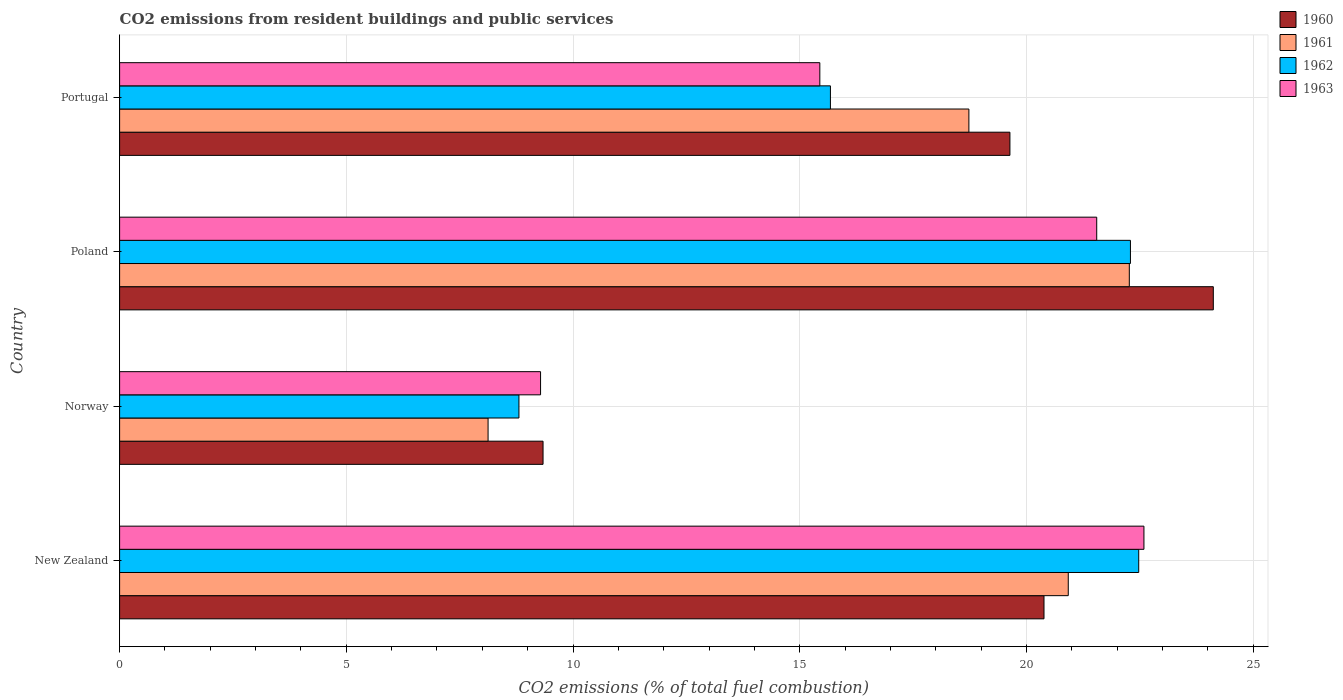Are the number of bars per tick equal to the number of legend labels?
Provide a short and direct response. Yes. Are the number of bars on each tick of the Y-axis equal?
Give a very brief answer. Yes. How many bars are there on the 1st tick from the bottom?
Keep it short and to the point. 4. What is the label of the 4th group of bars from the top?
Offer a terse response. New Zealand. In how many cases, is the number of bars for a given country not equal to the number of legend labels?
Your answer should be compact. 0. What is the total CO2 emitted in 1963 in Portugal?
Your response must be concise. 15.44. Across all countries, what is the maximum total CO2 emitted in 1963?
Make the answer very short. 22.59. Across all countries, what is the minimum total CO2 emitted in 1961?
Keep it short and to the point. 8.13. In which country was the total CO2 emitted in 1962 maximum?
Give a very brief answer. New Zealand. What is the total total CO2 emitted in 1963 in the graph?
Your response must be concise. 68.87. What is the difference between the total CO2 emitted in 1963 in Norway and that in Portugal?
Provide a succinct answer. -6.16. What is the difference between the total CO2 emitted in 1963 in Portugal and the total CO2 emitted in 1961 in Norway?
Offer a very short reply. 7.32. What is the average total CO2 emitted in 1962 per country?
Provide a succinct answer. 17.31. What is the difference between the total CO2 emitted in 1962 and total CO2 emitted in 1963 in Norway?
Provide a short and direct response. -0.48. In how many countries, is the total CO2 emitted in 1960 greater than 1 ?
Ensure brevity in your answer.  4. What is the ratio of the total CO2 emitted in 1960 in Poland to that in Portugal?
Keep it short and to the point. 1.23. Is the total CO2 emitted in 1962 in Poland less than that in Portugal?
Your response must be concise. No. Is the difference between the total CO2 emitted in 1962 in Norway and Poland greater than the difference between the total CO2 emitted in 1963 in Norway and Poland?
Ensure brevity in your answer.  No. What is the difference between the highest and the second highest total CO2 emitted in 1962?
Offer a terse response. 0.18. What is the difference between the highest and the lowest total CO2 emitted in 1960?
Keep it short and to the point. 14.78. Is it the case that in every country, the sum of the total CO2 emitted in 1962 and total CO2 emitted in 1961 is greater than the sum of total CO2 emitted in 1963 and total CO2 emitted in 1960?
Your response must be concise. No. What does the 1st bar from the top in Norway represents?
Provide a short and direct response. 1963. How many bars are there?
Offer a very short reply. 16. How many countries are there in the graph?
Give a very brief answer. 4. Does the graph contain grids?
Offer a terse response. Yes. Where does the legend appear in the graph?
Keep it short and to the point. Top right. How are the legend labels stacked?
Offer a terse response. Vertical. What is the title of the graph?
Give a very brief answer. CO2 emissions from resident buildings and public services. What is the label or title of the X-axis?
Provide a short and direct response. CO2 emissions (% of total fuel combustion). What is the CO2 emissions (% of total fuel combustion) in 1960 in New Zealand?
Your response must be concise. 20.39. What is the CO2 emissions (% of total fuel combustion) in 1961 in New Zealand?
Make the answer very short. 20.92. What is the CO2 emissions (% of total fuel combustion) of 1962 in New Zealand?
Offer a terse response. 22.48. What is the CO2 emissions (% of total fuel combustion) of 1963 in New Zealand?
Offer a terse response. 22.59. What is the CO2 emissions (% of total fuel combustion) in 1960 in Norway?
Ensure brevity in your answer.  9.34. What is the CO2 emissions (% of total fuel combustion) in 1961 in Norway?
Provide a short and direct response. 8.13. What is the CO2 emissions (% of total fuel combustion) in 1962 in Norway?
Your response must be concise. 8.81. What is the CO2 emissions (% of total fuel combustion) in 1963 in Norway?
Your answer should be compact. 9.28. What is the CO2 emissions (% of total fuel combustion) of 1960 in Poland?
Offer a terse response. 24.12. What is the CO2 emissions (% of total fuel combustion) in 1961 in Poland?
Provide a succinct answer. 22.27. What is the CO2 emissions (% of total fuel combustion) in 1962 in Poland?
Make the answer very short. 22.3. What is the CO2 emissions (% of total fuel combustion) of 1963 in Poland?
Make the answer very short. 21.55. What is the CO2 emissions (% of total fuel combustion) of 1960 in Portugal?
Give a very brief answer. 19.64. What is the CO2 emissions (% of total fuel combustion) of 1961 in Portugal?
Make the answer very short. 18.73. What is the CO2 emissions (% of total fuel combustion) in 1962 in Portugal?
Keep it short and to the point. 15.68. What is the CO2 emissions (% of total fuel combustion) in 1963 in Portugal?
Provide a short and direct response. 15.44. Across all countries, what is the maximum CO2 emissions (% of total fuel combustion) of 1960?
Offer a very short reply. 24.12. Across all countries, what is the maximum CO2 emissions (% of total fuel combustion) in 1961?
Offer a terse response. 22.27. Across all countries, what is the maximum CO2 emissions (% of total fuel combustion) in 1962?
Offer a very short reply. 22.48. Across all countries, what is the maximum CO2 emissions (% of total fuel combustion) in 1963?
Make the answer very short. 22.59. Across all countries, what is the minimum CO2 emissions (% of total fuel combustion) of 1960?
Provide a succinct answer. 9.34. Across all countries, what is the minimum CO2 emissions (% of total fuel combustion) of 1961?
Keep it short and to the point. 8.13. Across all countries, what is the minimum CO2 emissions (% of total fuel combustion) in 1962?
Offer a terse response. 8.81. Across all countries, what is the minimum CO2 emissions (% of total fuel combustion) in 1963?
Provide a short and direct response. 9.28. What is the total CO2 emissions (% of total fuel combustion) in 1960 in the graph?
Give a very brief answer. 73.49. What is the total CO2 emissions (% of total fuel combustion) in 1961 in the graph?
Your response must be concise. 70.05. What is the total CO2 emissions (% of total fuel combustion) of 1962 in the graph?
Provide a succinct answer. 69.26. What is the total CO2 emissions (% of total fuel combustion) in 1963 in the graph?
Your answer should be very brief. 68.87. What is the difference between the CO2 emissions (% of total fuel combustion) of 1960 in New Zealand and that in Norway?
Offer a very short reply. 11.05. What is the difference between the CO2 emissions (% of total fuel combustion) in 1961 in New Zealand and that in Norway?
Offer a very short reply. 12.8. What is the difference between the CO2 emissions (% of total fuel combustion) in 1962 in New Zealand and that in Norway?
Keep it short and to the point. 13.67. What is the difference between the CO2 emissions (% of total fuel combustion) of 1963 in New Zealand and that in Norway?
Ensure brevity in your answer.  13.31. What is the difference between the CO2 emissions (% of total fuel combustion) in 1960 in New Zealand and that in Poland?
Offer a terse response. -3.73. What is the difference between the CO2 emissions (% of total fuel combustion) in 1961 in New Zealand and that in Poland?
Give a very brief answer. -1.35. What is the difference between the CO2 emissions (% of total fuel combustion) in 1962 in New Zealand and that in Poland?
Provide a succinct answer. 0.18. What is the difference between the CO2 emissions (% of total fuel combustion) in 1963 in New Zealand and that in Poland?
Offer a terse response. 1.04. What is the difference between the CO2 emissions (% of total fuel combustion) of 1960 in New Zealand and that in Portugal?
Provide a short and direct response. 0.75. What is the difference between the CO2 emissions (% of total fuel combustion) in 1961 in New Zealand and that in Portugal?
Offer a very short reply. 2.19. What is the difference between the CO2 emissions (% of total fuel combustion) in 1962 in New Zealand and that in Portugal?
Give a very brief answer. 6.8. What is the difference between the CO2 emissions (% of total fuel combustion) of 1963 in New Zealand and that in Portugal?
Offer a terse response. 7.15. What is the difference between the CO2 emissions (% of total fuel combustion) in 1960 in Norway and that in Poland?
Make the answer very short. -14.78. What is the difference between the CO2 emissions (% of total fuel combustion) of 1961 in Norway and that in Poland?
Provide a succinct answer. -14.14. What is the difference between the CO2 emissions (% of total fuel combustion) of 1962 in Norway and that in Poland?
Your response must be concise. -13.49. What is the difference between the CO2 emissions (% of total fuel combustion) in 1963 in Norway and that in Poland?
Give a very brief answer. -12.27. What is the difference between the CO2 emissions (% of total fuel combustion) of 1960 in Norway and that in Portugal?
Give a very brief answer. -10.3. What is the difference between the CO2 emissions (% of total fuel combustion) in 1961 in Norway and that in Portugal?
Make the answer very short. -10.61. What is the difference between the CO2 emissions (% of total fuel combustion) in 1962 in Norway and that in Portugal?
Your answer should be very brief. -6.87. What is the difference between the CO2 emissions (% of total fuel combustion) of 1963 in Norway and that in Portugal?
Offer a terse response. -6.16. What is the difference between the CO2 emissions (% of total fuel combustion) of 1960 in Poland and that in Portugal?
Make the answer very short. 4.49. What is the difference between the CO2 emissions (% of total fuel combustion) of 1961 in Poland and that in Portugal?
Keep it short and to the point. 3.54. What is the difference between the CO2 emissions (% of total fuel combustion) of 1962 in Poland and that in Portugal?
Offer a terse response. 6.62. What is the difference between the CO2 emissions (% of total fuel combustion) of 1963 in Poland and that in Portugal?
Make the answer very short. 6.11. What is the difference between the CO2 emissions (% of total fuel combustion) of 1960 in New Zealand and the CO2 emissions (% of total fuel combustion) of 1961 in Norway?
Keep it short and to the point. 12.26. What is the difference between the CO2 emissions (% of total fuel combustion) in 1960 in New Zealand and the CO2 emissions (% of total fuel combustion) in 1962 in Norway?
Offer a very short reply. 11.58. What is the difference between the CO2 emissions (% of total fuel combustion) of 1960 in New Zealand and the CO2 emissions (% of total fuel combustion) of 1963 in Norway?
Provide a short and direct response. 11.1. What is the difference between the CO2 emissions (% of total fuel combustion) of 1961 in New Zealand and the CO2 emissions (% of total fuel combustion) of 1962 in Norway?
Give a very brief answer. 12.12. What is the difference between the CO2 emissions (% of total fuel combustion) in 1961 in New Zealand and the CO2 emissions (% of total fuel combustion) in 1963 in Norway?
Your response must be concise. 11.64. What is the difference between the CO2 emissions (% of total fuel combustion) of 1962 in New Zealand and the CO2 emissions (% of total fuel combustion) of 1963 in Norway?
Make the answer very short. 13.19. What is the difference between the CO2 emissions (% of total fuel combustion) of 1960 in New Zealand and the CO2 emissions (% of total fuel combustion) of 1961 in Poland?
Keep it short and to the point. -1.88. What is the difference between the CO2 emissions (% of total fuel combustion) of 1960 in New Zealand and the CO2 emissions (% of total fuel combustion) of 1962 in Poland?
Your answer should be compact. -1.91. What is the difference between the CO2 emissions (% of total fuel combustion) in 1960 in New Zealand and the CO2 emissions (% of total fuel combustion) in 1963 in Poland?
Provide a short and direct response. -1.16. What is the difference between the CO2 emissions (% of total fuel combustion) in 1961 in New Zealand and the CO2 emissions (% of total fuel combustion) in 1962 in Poland?
Provide a short and direct response. -1.37. What is the difference between the CO2 emissions (% of total fuel combustion) of 1961 in New Zealand and the CO2 emissions (% of total fuel combustion) of 1963 in Poland?
Offer a terse response. -0.63. What is the difference between the CO2 emissions (% of total fuel combustion) of 1962 in New Zealand and the CO2 emissions (% of total fuel combustion) of 1963 in Poland?
Your response must be concise. 0.93. What is the difference between the CO2 emissions (% of total fuel combustion) of 1960 in New Zealand and the CO2 emissions (% of total fuel combustion) of 1961 in Portugal?
Give a very brief answer. 1.66. What is the difference between the CO2 emissions (% of total fuel combustion) in 1960 in New Zealand and the CO2 emissions (% of total fuel combustion) in 1962 in Portugal?
Provide a succinct answer. 4.71. What is the difference between the CO2 emissions (% of total fuel combustion) of 1960 in New Zealand and the CO2 emissions (% of total fuel combustion) of 1963 in Portugal?
Offer a very short reply. 4.94. What is the difference between the CO2 emissions (% of total fuel combustion) of 1961 in New Zealand and the CO2 emissions (% of total fuel combustion) of 1962 in Portugal?
Provide a succinct answer. 5.25. What is the difference between the CO2 emissions (% of total fuel combustion) in 1961 in New Zealand and the CO2 emissions (% of total fuel combustion) in 1963 in Portugal?
Your response must be concise. 5.48. What is the difference between the CO2 emissions (% of total fuel combustion) in 1962 in New Zealand and the CO2 emissions (% of total fuel combustion) in 1963 in Portugal?
Keep it short and to the point. 7.03. What is the difference between the CO2 emissions (% of total fuel combustion) of 1960 in Norway and the CO2 emissions (% of total fuel combustion) of 1961 in Poland?
Ensure brevity in your answer.  -12.93. What is the difference between the CO2 emissions (% of total fuel combustion) of 1960 in Norway and the CO2 emissions (% of total fuel combustion) of 1962 in Poland?
Make the answer very short. -12.96. What is the difference between the CO2 emissions (% of total fuel combustion) in 1960 in Norway and the CO2 emissions (% of total fuel combustion) in 1963 in Poland?
Keep it short and to the point. -12.21. What is the difference between the CO2 emissions (% of total fuel combustion) of 1961 in Norway and the CO2 emissions (% of total fuel combustion) of 1962 in Poland?
Make the answer very short. -14.17. What is the difference between the CO2 emissions (% of total fuel combustion) of 1961 in Norway and the CO2 emissions (% of total fuel combustion) of 1963 in Poland?
Give a very brief answer. -13.42. What is the difference between the CO2 emissions (% of total fuel combustion) in 1962 in Norway and the CO2 emissions (% of total fuel combustion) in 1963 in Poland?
Offer a very short reply. -12.74. What is the difference between the CO2 emissions (% of total fuel combustion) in 1960 in Norway and the CO2 emissions (% of total fuel combustion) in 1961 in Portugal?
Make the answer very short. -9.39. What is the difference between the CO2 emissions (% of total fuel combustion) in 1960 in Norway and the CO2 emissions (% of total fuel combustion) in 1962 in Portugal?
Your answer should be very brief. -6.34. What is the difference between the CO2 emissions (% of total fuel combustion) of 1960 in Norway and the CO2 emissions (% of total fuel combustion) of 1963 in Portugal?
Offer a terse response. -6.1. What is the difference between the CO2 emissions (% of total fuel combustion) in 1961 in Norway and the CO2 emissions (% of total fuel combustion) in 1962 in Portugal?
Provide a succinct answer. -7.55. What is the difference between the CO2 emissions (% of total fuel combustion) in 1961 in Norway and the CO2 emissions (% of total fuel combustion) in 1963 in Portugal?
Provide a short and direct response. -7.32. What is the difference between the CO2 emissions (% of total fuel combustion) in 1962 in Norway and the CO2 emissions (% of total fuel combustion) in 1963 in Portugal?
Your answer should be compact. -6.64. What is the difference between the CO2 emissions (% of total fuel combustion) of 1960 in Poland and the CO2 emissions (% of total fuel combustion) of 1961 in Portugal?
Keep it short and to the point. 5.39. What is the difference between the CO2 emissions (% of total fuel combustion) of 1960 in Poland and the CO2 emissions (% of total fuel combustion) of 1962 in Portugal?
Provide a succinct answer. 8.44. What is the difference between the CO2 emissions (% of total fuel combustion) of 1960 in Poland and the CO2 emissions (% of total fuel combustion) of 1963 in Portugal?
Give a very brief answer. 8.68. What is the difference between the CO2 emissions (% of total fuel combustion) of 1961 in Poland and the CO2 emissions (% of total fuel combustion) of 1962 in Portugal?
Keep it short and to the point. 6.59. What is the difference between the CO2 emissions (% of total fuel combustion) of 1961 in Poland and the CO2 emissions (% of total fuel combustion) of 1963 in Portugal?
Your answer should be compact. 6.83. What is the difference between the CO2 emissions (% of total fuel combustion) of 1962 in Poland and the CO2 emissions (% of total fuel combustion) of 1963 in Portugal?
Make the answer very short. 6.85. What is the average CO2 emissions (% of total fuel combustion) of 1960 per country?
Ensure brevity in your answer.  18.37. What is the average CO2 emissions (% of total fuel combustion) in 1961 per country?
Make the answer very short. 17.51. What is the average CO2 emissions (% of total fuel combustion) in 1962 per country?
Provide a short and direct response. 17.31. What is the average CO2 emissions (% of total fuel combustion) of 1963 per country?
Make the answer very short. 17.22. What is the difference between the CO2 emissions (% of total fuel combustion) of 1960 and CO2 emissions (% of total fuel combustion) of 1961 in New Zealand?
Give a very brief answer. -0.54. What is the difference between the CO2 emissions (% of total fuel combustion) in 1960 and CO2 emissions (% of total fuel combustion) in 1962 in New Zealand?
Your response must be concise. -2.09. What is the difference between the CO2 emissions (% of total fuel combustion) in 1960 and CO2 emissions (% of total fuel combustion) in 1963 in New Zealand?
Offer a very short reply. -2.2. What is the difference between the CO2 emissions (% of total fuel combustion) in 1961 and CO2 emissions (% of total fuel combustion) in 1962 in New Zealand?
Ensure brevity in your answer.  -1.55. What is the difference between the CO2 emissions (% of total fuel combustion) of 1961 and CO2 emissions (% of total fuel combustion) of 1963 in New Zealand?
Ensure brevity in your answer.  -1.67. What is the difference between the CO2 emissions (% of total fuel combustion) of 1962 and CO2 emissions (% of total fuel combustion) of 1963 in New Zealand?
Your answer should be compact. -0.12. What is the difference between the CO2 emissions (% of total fuel combustion) in 1960 and CO2 emissions (% of total fuel combustion) in 1961 in Norway?
Offer a very short reply. 1.21. What is the difference between the CO2 emissions (% of total fuel combustion) in 1960 and CO2 emissions (% of total fuel combustion) in 1962 in Norway?
Your answer should be compact. 0.53. What is the difference between the CO2 emissions (% of total fuel combustion) of 1960 and CO2 emissions (% of total fuel combustion) of 1963 in Norway?
Offer a terse response. 0.05. What is the difference between the CO2 emissions (% of total fuel combustion) of 1961 and CO2 emissions (% of total fuel combustion) of 1962 in Norway?
Your answer should be very brief. -0.68. What is the difference between the CO2 emissions (% of total fuel combustion) in 1961 and CO2 emissions (% of total fuel combustion) in 1963 in Norway?
Make the answer very short. -1.16. What is the difference between the CO2 emissions (% of total fuel combustion) of 1962 and CO2 emissions (% of total fuel combustion) of 1963 in Norway?
Keep it short and to the point. -0.48. What is the difference between the CO2 emissions (% of total fuel combustion) of 1960 and CO2 emissions (% of total fuel combustion) of 1961 in Poland?
Provide a short and direct response. 1.85. What is the difference between the CO2 emissions (% of total fuel combustion) of 1960 and CO2 emissions (% of total fuel combustion) of 1962 in Poland?
Provide a short and direct response. 1.83. What is the difference between the CO2 emissions (% of total fuel combustion) of 1960 and CO2 emissions (% of total fuel combustion) of 1963 in Poland?
Ensure brevity in your answer.  2.57. What is the difference between the CO2 emissions (% of total fuel combustion) in 1961 and CO2 emissions (% of total fuel combustion) in 1962 in Poland?
Your answer should be very brief. -0.02. What is the difference between the CO2 emissions (% of total fuel combustion) of 1961 and CO2 emissions (% of total fuel combustion) of 1963 in Poland?
Your answer should be compact. 0.72. What is the difference between the CO2 emissions (% of total fuel combustion) of 1962 and CO2 emissions (% of total fuel combustion) of 1963 in Poland?
Your answer should be very brief. 0.74. What is the difference between the CO2 emissions (% of total fuel combustion) in 1960 and CO2 emissions (% of total fuel combustion) in 1961 in Portugal?
Your answer should be very brief. 0.91. What is the difference between the CO2 emissions (% of total fuel combustion) in 1960 and CO2 emissions (% of total fuel combustion) in 1962 in Portugal?
Make the answer very short. 3.96. What is the difference between the CO2 emissions (% of total fuel combustion) in 1960 and CO2 emissions (% of total fuel combustion) in 1963 in Portugal?
Give a very brief answer. 4.19. What is the difference between the CO2 emissions (% of total fuel combustion) of 1961 and CO2 emissions (% of total fuel combustion) of 1962 in Portugal?
Give a very brief answer. 3.05. What is the difference between the CO2 emissions (% of total fuel combustion) of 1961 and CO2 emissions (% of total fuel combustion) of 1963 in Portugal?
Offer a very short reply. 3.29. What is the difference between the CO2 emissions (% of total fuel combustion) of 1962 and CO2 emissions (% of total fuel combustion) of 1963 in Portugal?
Offer a very short reply. 0.23. What is the ratio of the CO2 emissions (% of total fuel combustion) in 1960 in New Zealand to that in Norway?
Offer a very short reply. 2.18. What is the ratio of the CO2 emissions (% of total fuel combustion) in 1961 in New Zealand to that in Norway?
Ensure brevity in your answer.  2.57. What is the ratio of the CO2 emissions (% of total fuel combustion) of 1962 in New Zealand to that in Norway?
Offer a very short reply. 2.55. What is the ratio of the CO2 emissions (% of total fuel combustion) of 1963 in New Zealand to that in Norway?
Offer a very short reply. 2.43. What is the ratio of the CO2 emissions (% of total fuel combustion) of 1960 in New Zealand to that in Poland?
Make the answer very short. 0.85. What is the ratio of the CO2 emissions (% of total fuel combustion) of 1961 in New Zealand to that in Poland?
Provide a short and direct response. 0.94. What is the ratio of the CO2 emissions (% of total fuel combustion) in 1962 in New Zealand to that in Poland?
Provide a short and direct response. 1.01. What is the ratio of the CO2 emissions (% of total fuel combustion) of 1963 in New Zealand to that in Poland?
Provide a succinct answer. 1.05. What is the ratio of the CO2 emissions (% of total fuel combustion) in 1960 in New Zealand to that in Portugal?
Make the answer very short. 1.04. What is the ratio of the CO2 emissions (% of total fuel combustion) in 1961 in New Zealand to that in Portugal?
Offer a terse response. 1.12. What is the ratio of the CO2 emissions (% of total fuel combustion) of 1962 in New Zealand to that in Portugal?
Keep it short and to the point. 1.43. What is the ratio of the CO2 emissions (% of total fuel combustion) of 1963 in New Zealand to that in Portugal?
Ensure brevity in your answer.  1.46. What is the ratio of the CO2 emissions (% of total fuel combustion) in 1960 in Norway to that in Poland?
Provide a succinct answer. 0.39. What is the ratio of the CO2 emissions (% of total fuel combustion) of 1961 in Norway to that in Poland?
Offer a terse response. 0.36. What is the ratio of the CO2 emissions (% of total fuel combustion) of 1962 in Norway to that in Poland?
Your answer should be very brief. 0.4. What is the ratio of the CO2 emissions (% of total fuel combustion) of 1963 in Norway to that in Poland?
Keep it short and to the point. 0.43. What is the ratio of the CO2 emissions (% of total fuel combustion) in 1960 in Norway to that in Portugal?
Keep it short and to the point. 0.48. What is the ratio of the CO2 emissions (% of total fuel combustion) in 1961 in Norway to that in Portugal?
Offer a very short reply. 0.43. What is the ratio of the CO2 emissions (% of total fuel combustion) in 1962 in Norway to that in Portugal?
Your response must be concise. 0.56. What is the ratio of the CO2 emissions (% of total fuel combustion) of 1963 in Norway to that in Portugal?
Ensure brevity in your answer.  0.6. What is the ratio of the CO2 emissions (% of total fuel combustion) in 1960 in Poland to that in Portugal?
Make the answer very short. 1.23. What is the ratio of the CO2 emissions (% of total fuel combustion) of 1961 in Poland to that in Portugal?
Your response must be concise. 1.19. What is the ratio of the CO2 emissions (% of total fuel combustion) in 1962 in Poland to that in Portugal?
Ensure brevity in your answer.  1.42. What is the ratio of the CO2 emissions (% of total fuel combustion) in 1963 in Poland to that in Portugal?
Provide a short and direct response. 1.4. What is the difference between the highest and the second highest CO2 emissions (% of total fuel combustion) of 1960?
Your answer should be very brief. 3.73. What is the difference between the highest and the second highest CO2 emissions (% of total fuel combustion) in 1961?
Keep it short and to the point. 1.35. What is the difference between the highest and the second highest CO2 emissions (% of total fuel combustion) of 1962?
Keep it short and to the point. 0.18. What is the difference between the highest and the second highest CO2 emissions (% of total fuel combustion) of 1963?
Your answer should be compact. 1.04. What is the difference between the highest and the lowest CO2 emissions (% of total fuel combustion) in 1960?
Make the answer very short. 14.78. What is the difference between the highest and the lowest CO2 emissions (% of total fuel combustion) in 1961?
Offer a terse response. 14.14. What is the difference between the highest and the lowest CO2 emissions (% of total fuel combustion) in 1962?
Give a very brief answer. 13.67. What is the difference between the highest and the lowest CO2 emissions (% of total fuel combustion) in 1963?
Make the answer very short. 13.31. 